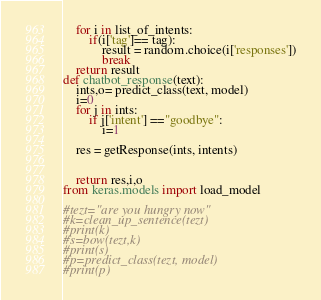<code> <loc_0><loc_0><loc_500><loc_500><_Python_>    for i in list_of_intents:
        if(i['tag']== tag):
            result = random.choice(i['responses'])
            break
    return result
def chatbot_response(text):
    ints,o= predict_class(text, model)
    i=0
    for j in ints:
        if j['intent'] =="goodbye":
            i=1
    
    res = getResponse(ints, intents)
    
    
    return res,i,o
from keras.models import load_model

#tezt="are you hungry now"
#k=clean_up_sentence(tezt)
#print(k)
#s=bow(tezt,k)
#print(s)
#p=predict_class(tezt, model)
#print(p)
</code> 